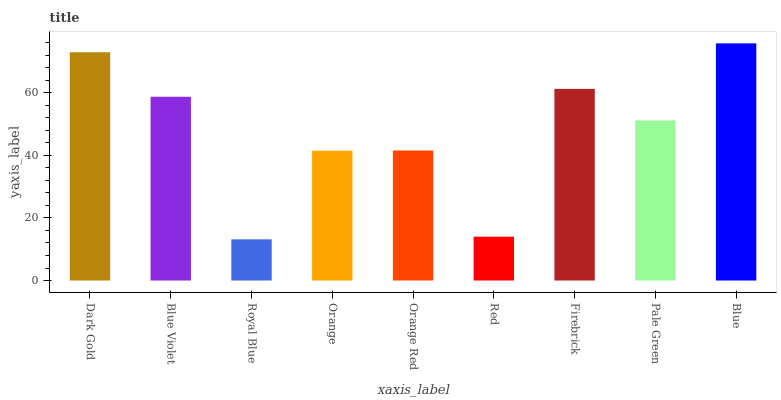Is Royal Blue the minimum?
Answer yes or no. Yes. Is Blue the maximum?
Answer yes or no. Yes. Is Blue Violet the minimum?
Answer yes or no. No. Is Blue Violet the maximum?
Answer yes or no. No. Is Dark Gold greater than Blue Violet?
Answer yes or no. Yes. Is Blue Violet less than Dark Gold?
Answer yes or no. Yes. Is Blue Violet greater than Dark Gold?
Answer yes or no. No. Is Dark Gold less than Blue Violet?
Answer yes or no. No. Is Pale Green the high median?
Answer yes or no. Yes. Is Pale Green the low median?
Answer yes or no. Yes. Is Dark Gold the high median?
Answer yes or no. No. Is Royal Blue the low median?
Answer yes or no. No. 